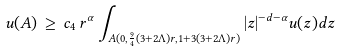<formula> <loc_0><loc_0><loc_500><loc_500>u ( A ) \, \geq \, c _ { 4 } \, r ^ { \alpha } \int _ { A ( 0 , \frac { 9 } { 4 } ( 3 + 2 \Lambda ) r , 1 + 3 ( 3 + 2 \Lambda ) r ) } | z | ^ { - d - \alpha } u ( z ) d z</formula> 